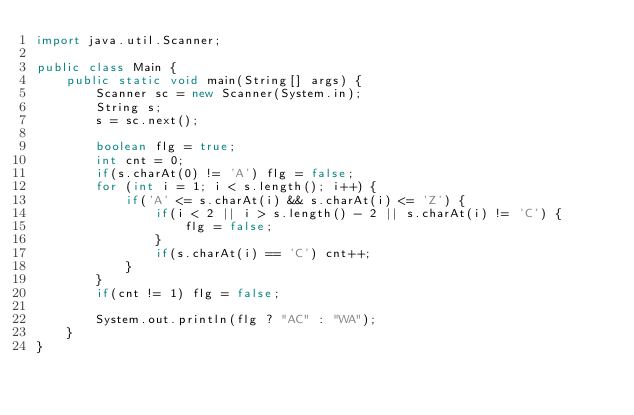Convert code to text. <code><loc_0><loc_0><loc_500><loc_500><_Java_>import java.util.Scanner;

public class Main {
	public static void main(String[] args) {
		Scanner sc = new Scanner(System.in);
		String s;
		s = sc.next();

		boolean flg = true;
		int cnt = 0;
		if(s.charAt(0) != 'A') flg = false;
		for (int i = 1; i < s.length(); i++) {
			if('A' <= s.charAt(i) && s.charAt(i) <= 'Z') {
				if(i < 2 || i > s.length() - 2 || s.charAt(i) != 'C') {
					flg = false;
				}
				if(s.charAt(i) == 'C') cnt++;
			}
		}
		if(cnt != 1) flg = false;

		System.out.println(flg ? "AC" : "WA");
	}
}</code> 